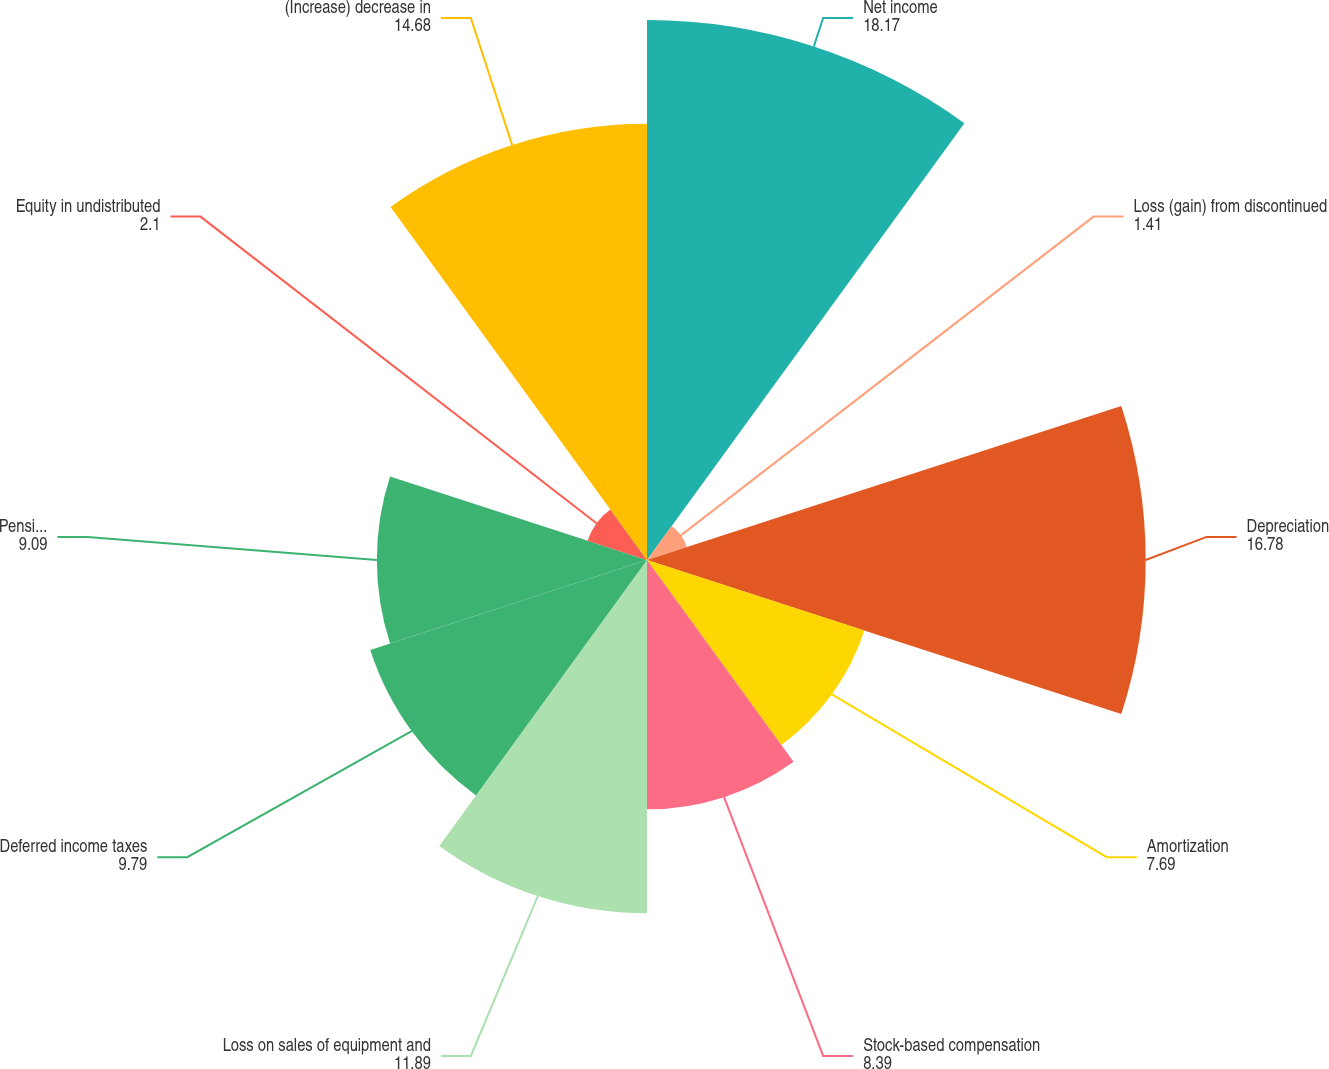<chart> <loc_0><loc_0><loc_500><loc_500><pie_chart><fcel>Net income<fcel>Loss (gain) from discontinued<fcel>Depreciation<fcel>Amortization<fcel>Stock-based compensation<fcel>Loss on sales of equipment and<fcel>Deferred income taxes<fcel>Pension and other retirement<fcel>Equity in undistributed<fcel>(Increase) decrease in<nl><fcel>18.17%<fcel>1.41%<fcel>16.78%<fcel>7.69%<fcel>8.39%<fcel>11.89%<fcel>9.79%<fcel>9.09%<fcel>2.1%<fcel>14.68%<nl></chart> 